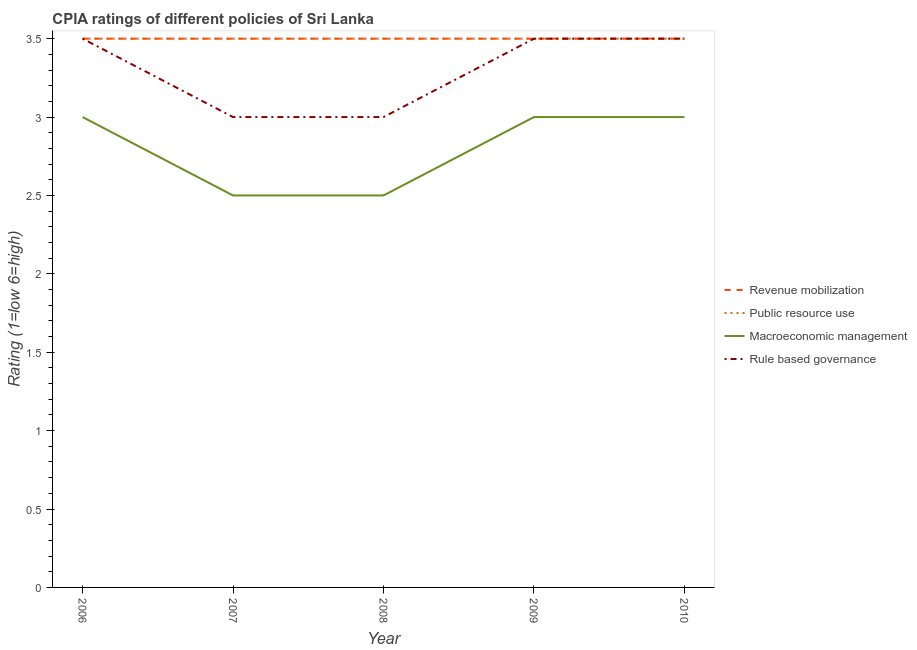How many different coloured lines are there?
Give a very brief answer. 4. Does the line corresponding to cpia rating of macroeconomic management intersect with the line corresponding to cpia rating of revenue mobilization?
Provide a short and direct response. No. Is the number of lines equal to the number of legend labels?
Ensure brevity in your answer.  Yes. What is the cpia rating of macroeconomic management in 2007?
Your response must be concise. 2.5. Across all years, what is the maximum cpia rating of revenue mobilization?
Your answer should be compact. 3.5. In which year was the cpia rating of rule based governance minimum?
Make the answer very short. 2007. What is the difference between the cpia rating of rule based governance in 2008 and that in 2010?
Give a very brief answer. -0.5. What is the difference between the cpia rating of public resource use in 2009 and the cpia rating of rule based governance in 2008?
Your answer should be compact. 0.5. What is the average cpia rating of macroeconomic management per year?
Keep it short and to the point. 2.8. In the year 2009, what is the difference between the cpia rating of macroeconomic management and cpia rating of revenue mobilization?
Provide a short and direct response. -0.5. Is the cpia rating of revenue mobilization in 2006 less than that in 2007?
Provide a succinct answer. No. What is the difference between the highest and the lowest cpia rating of revenue mobilization?
Keep it short and to the point. 0. In how many years, is the cpia rating of rule based governance greater than the average cpia rating of rule based governance taken over all years?
Make the answer very short. 3. Is it the case that in every year, the sum of the cpia rating of macroeconomic management and cpia rating of revenue mobilization is greater than the sum of cpia rating of rule based governance and cpia rating of public resource use?
Ensure brevity in your answer.  No. Is it the case that in every year, the sum of the cpia rating of revenue mobilization and cpia rating of public resource use is greater than the cpia rating of macroeconomic management?
Offer a very short reply. Yes. Is the cpia rating of rule based governance strictly greater than the cpia rating of macroeconomic management over the years?
Your answer should be compact. Yes. Is the cpia rating of revenue mobilization strictly less than the cpia rating of rule based governance over the years?
Provide a succinct answer. No. How many lines are there?
Your answer should be very brief. 4. How many years are there in the graph?
Provide a short and direct response. 5. What is the difference between two consecutive major ticks on the Y-axis?
Provide a succinct answer. 0.5. How many legend labels are there?
Provide a succinct answer. 4. How are the legend labels stacked?
Give a very brief answer. Vertical. What is the title of the graph?
Keep it short and to the point. CPIA ratings of different policies of Sri Lanka. What is the label or title of the X-axis?
Provide a short and direct response. Year. What is the label or title of the Y-axis?
Give a very brief answer. Rating (1=low 6=high). What is the Rating (1=low 6=high) of Public resource use in 2006?
Your answer should be very brief. 3.5. What is the Rating (1=low 6=high) in Rule based governance in 2006?
Provide a short and direct response. 3.5. What is the Rating (1=low 6=high) in Revenue mobilization in 2007?
Ensure brevity in your answer.  3.5. What is the Rating (1=low 6=high) of Revenue mobilization in 2008?
Offer a very short reply. 3.5. What is the Rating (1=low 6=high) in Public resource use in 2008?
Provide a short and direct response. 3.5. What is the Rating (1=low 6=high) in Rule based governance in 2008?
Make the answer very short. 3. What is the Rating (1=low 6=high) in Revenue mobilization in 2009?
Your answer should be compact. 3.5. What is the Rating (1=low 6=high) in Public resource use in 2009?
Your answer should be compact. 3.5. What is the Rating (1=low 6=high) of Revenue mobilization in 2010?
Make the answer very short. 3.5. What is the Rating (1=low 6=high) of Macroeconomic management in 2010?
Offer a very short reply. 3. Across all years, what is the maximum Rating (1=low 6=high) in Revenue mobilization?
Your response must be concise. 3.5. Across all years, what is the maximum Rating (1=low 6=high) of Macroeconomic management?
Your answer should be very brief. 3. Across all years, what is the maximum Rating (1=low 6=high) of Rule based governance?
Offer a very short reply. 3.5. Across all years, what is the minimum Rating (1=low 6=high) of Public resource use?
Provide a succinct answer. 3.5. What is the total Rating (1=low 6=high) in Revenue mobilization in the graph?
Offer a very short reply. 17.5. What is the total Rating (1=low 6=high) of Macroeconomic management in the graph?
Your answer should be compact. 14. What is the total Rating (1=low 6=high) in Rule based governance in the graph?
Your answer should be compact. 16.5. What is the difference between the Rating (1=low 6=high) in Macroeconomic management in 2006 and that in 2007?
Your answer should be very brief. 0.5. What is the difference between the Rating (1=low 6=high) in Revenue mobilization in 2006 and that in 2008?
Your response must be concise. 0. What is the difference between the Rating (1=low 6=high) of Public resource use in 2006 and that in 2008?
Ensure brevity in your answer.  0. What is the difference between the Rating (1=low 6=high) in Revenue mobilization in 2006 and that in 2009?
Provide a short and direct response. 0. What is the difference between the Rating (1=low 6=high) of Macroeconomic management in 2006 and that in 2009?
Make the answer very short. 0. What is the difference between the Rating (1=low 6=high) of Public resource use in 2006 and that in 2010?
Offer a very short reply. 0. What is the difference between the Rating (1=low 6=high) in Revenue mobilization in 2007 and that in 2008?
Provide a short and direct response. 0. What is the difference between the Rating (1=low 6=high) in Public resource use in 2007 and that in 2008?
Offer a terse response. 0. What is the difference between the Rating (1=low 6=high) of Rule based governance in 2007 and that in 2008?
Provide a succinct answer. 0. What is the difference between the Rating (1=low 6=high) in Revenue mobilization in 2007 and that in 2010?
Offer a very short reply. 0. What is the difference between the Rating (1=low 6=high) in Revenue mobilization in 2008 and that in 2010?
Provide a succinct answer. 0. What is the difference between the Rating (1=low 6=high) in Public resource use in 2008 and that in 2010?
Provide a succinct answer. 0. What is the difference between the Rating (1=low 6=high) of Macroeconomic management in 2008 and that in 2010?
Your answer should be compact. -0.5. What is the difference between the Rating (1=low 6=high) of Revenue mobilization in 2009 and that in 2010?
Give a very brief answer. 0. What is the difference between the Rating (1=low 6=high) of Public resource use in 2009 and that in 2010?
Your response must be concise. 0. What is the difference between the Rating (1=low 6=high) of Macroeconomic management in 2009 and that in 2010?
Provide a succinct answer. 0. What is the difference between the Rating (1=low 6=high) in Revenue mobilization in 2006 and the Rating (1=low 6=high) in Public resource use in 2007?
Provide a succinct answer. 0. What is the difference between the Rating (1=low 6=high) of Revenue mobilization in 2006 and the Rating (1=low 6=high) of Rule based governance in 2007?
Keep it short and to the point. 0.5. What is the difference between the Rating (1=low 6=high) of Public resource use in 2006 and the Rating (1=low 6=high) of Macroeconomic management in 2007?
Provide a succinct answer. 1. What is the difference between the Rating (1=low 6=high) in Macroeconomic management in 2006 and the Rating (1=low 6=high) in Rule based governance in 2007?
Ensure brevity in your answer.  0. What is the difference between the Rating (1=low 6=high) in Revenue mobilization in 2006 and the Rating (1=low 6=high) in Macroeconomic management in 2008?
Keep it short and to the point. 1. What is the difference between the Rating (1=low 6=high) in Public resource use in 2006 and the Rating (1=low 6=high) in Macroeconomic management in 2008?
Your answer should be compact. 1. What is the difference between the Rating (1=low 6=high) in Revenue mobilization in 2006 and the Rating (1=low 6=high) in Public resource use in 2009?
Provide a short and direct response. 0. What is the difference between the Rating (1=low 6=high) in Revenue mobilization in 2006 and the Rating (1=low 6=high) in Macroeconomic management in 2009?
Your answer should be very brief. 0.5. What is the difference between the Rating (1=low 6=high) of Public resource use in 2006 and the Rating (1=low 6=high) of Macroeconomic management in 2009?
Offer a very short reply. 0.5. What is the difference between the Rating (1=low 6=high) in Public resource use in 2006 and the Rating (1=low 6=high) in Rule based governance in 2009?
Provide a succinct answer. 0. What is the difference between the Rating (1=low 6=high) of Revenue mobilization in 2006 and the Rating (1=low 6=high) of Macroeconomic management in 2010?
Provide a short and direct response. 0.5. What is the difference between the Rating (1=low 6=high) of Revenue mobilization in 2006 and the Rating (1=low 6=high) of Rule based governance in 2010?
Offer a very short reply. 0. What is the difference between the Rating (1=low 6=high) in Public resource use in 2006 and the Rating (1=low 6=high) in Rule based governance in 2010?
Keep it short and to the point. 0. What is the difference between the Rating (1=low 6=high) of Macroeconomic management in 2006 and the Rating (1=low 6=high) of Rule based governance in 2010?
Provide a short and direct response. -0.5. What is the difference between the Rating (1=low 6=high) of Revenue mobilization in 2007 and the Rating (1=low 6=high) of Public resource use in 2008?
Provide a succinct answer. 0. What is the difference between the Rating (1=low 6=high) of Public resource use in 2007 and the Rating (1=low 6=high) of Macroeconomic management in 2008?
Ensure brevity in your answer.  1. What is the difference between the Rating (1=low 6=high) of Revenue mobilization in 2007 and the Rating (1=low 6=high) of Macroeconomic management in 2009?
Offer a very short reply. 0.5. What is the difference between the Rating (1=low 6=high) of Public resource use in 2007 and the Rating (1=low 6=high) of Macroeconomic management in 2009?
Provide a short and direct response. 0.5. What is the difference between the Rating (1=low 6=high) of Public resource use in 2007 and the Rating (1=low 6=high) of Rule based governance in 2009?
Make the answer very short. 0. What is the difference between the Rating (1=low 6=high) in Revenue mobilization in 2007 and the Rating (1=low 6=high) in Public resource use in 2010?
Offer a terse response. 0. What is the difference between the Rating (1=low 6=high) in Revenue mobilization in 2007 and the Rating (1=low 6=high) in Rule based governance in 2010?
Keep it short and to the point. 0. What is the difference between the Rating (1=low 6=high) in Public resource use in 2007 and the Rating (1=low 6=high) in Rule based governance in 2010?
Your answer should be compact. 0. What is the difference between the Rating (1=low 6=high) of Macroeconomic management in 2007 and the Rating (1=low 6=high) of Rule based governance in 2010?
Offer a very short reply. -1. What is the difference between the Rating (1=low 6=high) in Revenue mobilization in 2008 and the Rating (1=low 6=high) in Public resource use in 2009?
Provide a succinct answer. 0. What is the difference between the Rating (1=low 6=high) in Revenue mobilization in 2008 and the Rating (1=low 6=high) in Rule based governance in 2009?
Your response must be concise. 0. What is the difference between the Rating (1=low 6=high) in Macroeconomic management in 2008 and the Rating (1=low 6=high) in Rule based governance in 2009?
Your answer should be compact. -1. What is the difference between the Rating (1=low 6=high) of Revenue mobilization in 2008 and the Rating (1=low 6=high) of Public resource use in 2010?
Your answer should be very brief. 0. What is the difference between the Rating (1=low 6=high) of Revenue mobilization in 2008 and the Rating (1=low 6=high) of Macroeconomic management in 2010?
Keep it short and to the point. 0.5. What is the difference between the Rating (1=low 6=high) in Public resource use in 2008 and the Rating (1=low 6=high) in Macroeconomic management in 2010?
Offer a terse response. 0.5. What is the difference between the Rating (1=low 6=high) in Public resource use in 2008 and the Rating (1=low 6=high) in Rule based governance in 2010?
Keep it short and to the point. 0. What is the difference between the Rating (1=low 6=high) in Revenue mobilization in 2009 and the Rating (1=low 6=high) in Public resource use in 2010?
Give a very brief answer. 0. What is the difference between the Rating (1=low 6=high) of Revenue mobilization in 2009 and the Rating (1=low 6=high) of Macroeconomic management in 2010?
Your answer should be compact. 0.5. What is the average Rating (1=low 6=high) in Revenue mobilization per year?
Make the answer very short. 3.5. What is the average Rating (1=low 6=high) in Rule based governance per year?
Provide a succinct answer. 3.3. In the year 2006, what is the difference between the Rating (1=low 6=high) of Revenue mobilization and Rating (1=low 6=high) of Macroeconomic management?
Make the answer very short. 0.5. In the year 2006, what is the difference between the Rating (1=low 6=high) in Macroeconomic management and Rating (1=low 6=high) in Rule based governance?
Provide a succinct answer. -0.5. In the year 2007, what is the difference between the Rating (1=low 6=high) of Revenue mobilization and Rating (1=low 6=high) of Macroeconomic management?
Make the answer very short. 1. In the year 2007, what is the difference between the Rating (1=low 6=high) in Revenue mobilization and Rating (1=low 6=high) in Rule based governance?
Provide a short and direct response. 0.5. In the year 2007, what is the difference between the Rating (1=low 6=high) of Public resource use and Rating (1=low 6=high) of Macroeconomic management?
Provide a short and direct response. 1. In the year 2007, what is the difference between the Rating (1=low 6=high) in Public resource use and Rating (1=low 6=high) in Rule based governance?
Give a very brief answer. 0.5. In the year 2008, what is the difference between the Rating (1=low 6=high) of Revenue mobilization and Rating (1=low 6=high) of Public resource use?
Offer a very short reply. 0. In the year 2008, what is the difference between the Rating (1=low 6=high) of Macroeconomic management and Rating (1=low 6=high) of Rule based governance?
Ensure brevity in your answer.  -0.5. In the year 2009, what is the difference between the Rating (1=low 6=high) in Revenue mobilization and Rating (1=low 6=high) in Rule based governance?
Provide a short and direct response. 0. In the year 2009, what is the difference between the Rating (1=low 6=high) of Public resource use and Rating (1=low 6=high) of Rule based governance?
Provide a short and direct response. 0. In the year 2010, what is the difference between the Rating (1=low 6=high) in Revenue mobilization and Rating (1=low 6=high) in Public resource use?
Your answer should be very brief. 0. In the year 2010, what is the difference between the Rating (1=low 6=high) in Revenue mobilization and Rating (1=low 6=high) in Macroeconomic management?
Provide a short and direct response. 0.5. In the year 2010, what is the difference between the Rating (1=low 6=high) in Revenue mobilization and Rating (1=low 6=high) in Rule based governance?
Ensure brevity in your answer.  0. In the year 2010, what is the difference between the Rating (1=low 6=high) of Public resource use and Rating (1=low 6=high) of Macroeconomic management?
Offer a terse response. 0.5. What is the ratio of the Rating (1=low 6=high) of Public resource use in 2006 to that in 2007?
Ensure brevity in your answer.  1. What is the ratio of the Rating (1=low 6=high) in Macroeconomic management in 2006 to that in 2007?
Your answer should be very brief. 1.2. What is the ratio of the Rating (1=low 6=high) in Revenue mobilization in 2006 to that in 2008?
Your response must be concise. 1. What is the ratio of the Rating (1=low 6=high) in Rule based governance in 2006 to that in 2008?
Your answer should be compact. 1.17. What is the ratio of the Rating (1=low 6=high) of Public resource use in 2006 to that in 2009?
Keep it short and to the point. 1. What is the ratio of the Rating (1=low 6=high) in Macroeconomic management in 2006 to that in 2009?
Give a very brief answer. 1. What is the ratio of the Rating (1=low 6=high) of Rule based governance in 2006 to that in 2009?
Offer a terse response. 1. What is the ratio of the Rating (1=low 6=high) of Revenue mobilization in 2006 to that in 2010?
Your answer should be compact. 1. What is the ratio of the Rating (1=low 6=high) of Public resource use in 2006 to that in 2010?
Provide a short and direct response. 1. What is the ratio of the Rating (1=low 6=high) of Revenue mobilization in 2007 to that in 2008?
Keep it short and to the point. 1. What is the ratio of the Rating (1=low 6=high) of Public resource use in 2007 to that in 2008?
Your answer should be very brief. 1. What is the ratio of the Rating (1=low 6=high) in Macroeconomic management in 2007 to that in 2009?
Your answer should be compact. 0.83. What is the ratio of the Rating (1=low 6=high) in Public resource use in 2007 to that in 2010?
Give a very brief answer. 1. What is the ratio of the Rating (1=low 6=high) in Rule based governance in 2007 to that in 2010?
Offer a very short reply. 0.86. What is the ratio of the Rating (1=low 6=high) in Revenue mobilization in 2008 to that in 2009?
Ensure brevity in your answer.  1. What is the ratio of the Rating (1=low 6=high) in Rule based governance in 2008 to that in 2009?
Offer a terse response. 0.86. What is the ratio of the Rating (1=low 6=high) in Revenue mobilization in 2008 to that in 2010?
Your answer should be compact. 1. What is the ratio of the Rating (1=low 6=high) of Public resource use in 2008 to that in 2010?
Keep it short and to the point. 1. What is the ratio of the Rating (1=low 6=high) in Rule based governance in 2008 to that in 2010?
Your response must be concise. 0.86. What is the ratio of the Rating (1=low 6=high) in Revenue mobilization in 2009 to that in 2010?
Provide a short and direct response. 1. What is the difference between the highest and the second highest Rating (1=low 6=high) of Public resource use?
Your answer should be compact. 0. What is the difference between the highest and the lowest Rating (1=low 6=high) in Revenue mobilization?
Give a very brief answer. 0. What is the difference between the highest and the lowest Rating (1=low 6=high) of Macroeconomic management?
Your answer should be compact. 0.5. 